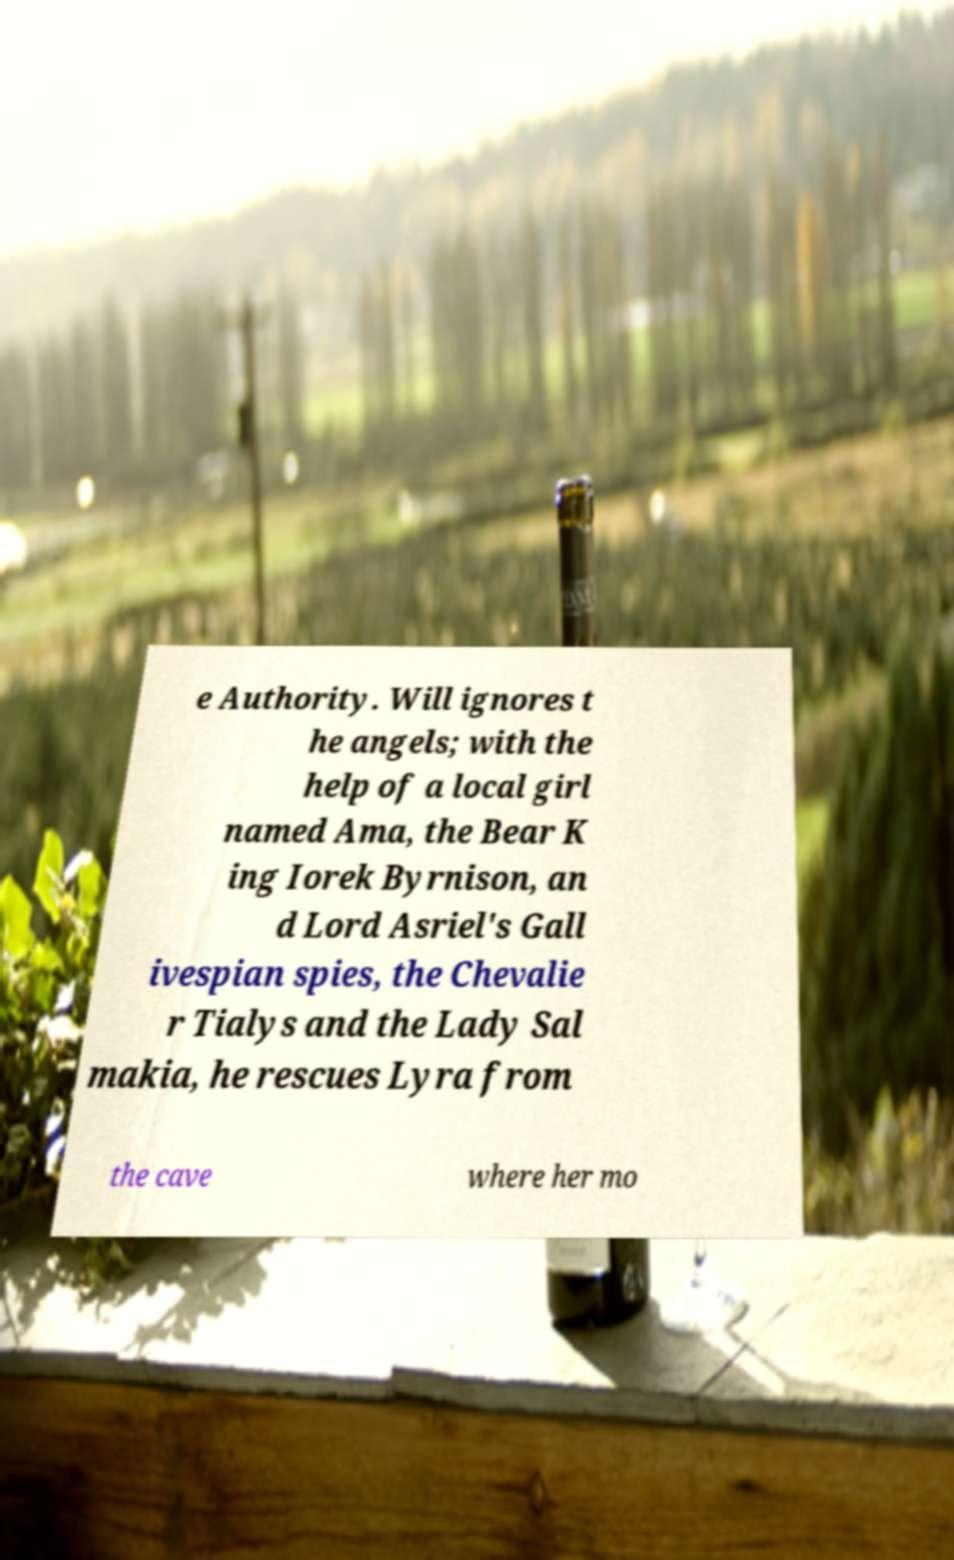For documentation purposes, I need the text within this image transcribed. Could you provide that? e Authority. Will ignores t he angels; with the help of a local girl named Ama, the Bear K ing Iorek Byrnison, an d Lord Asriel's Gall ivespian spies, the Chevalie r Tialys and the Lady Sal makia, he rescues Lyra from the cave where her mo 